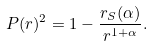Convert formula to latex. <formula><loc_0><loc_0><loc_500><loc_500>P ( r ) ^ { 2 } = 1 - \frac { r _ { S } ( \alpha ) } { r ^ { 1 + \alpha } } .</formula> 